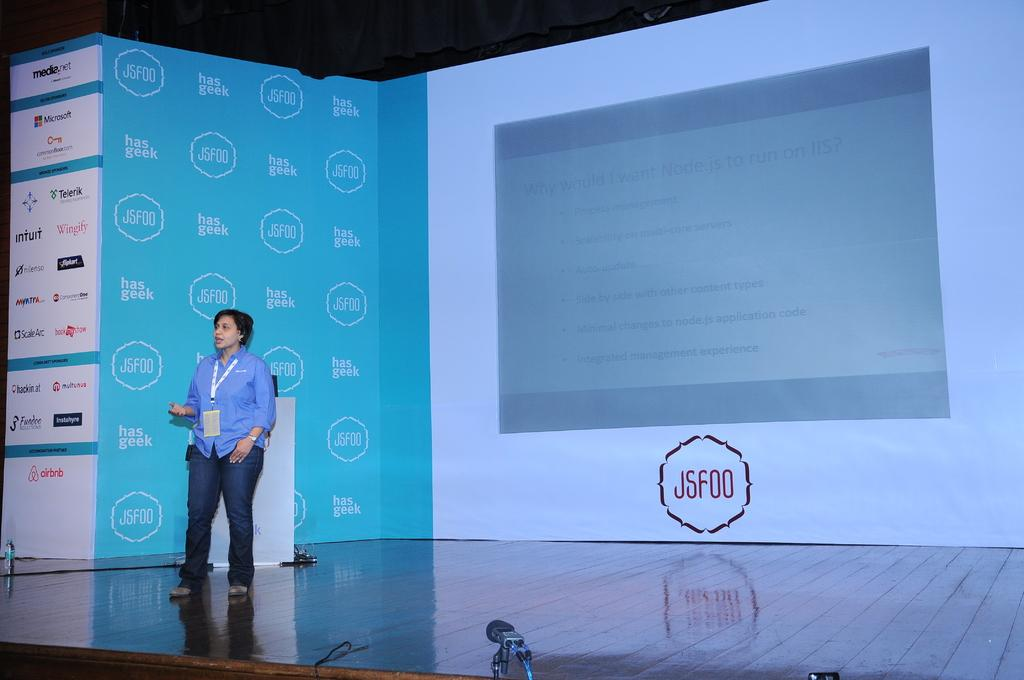What is the main subject of the image? There is a person standing in the image. What can be seen at the bottom of the image? There are objects at the bottom of the image. Where is the bottle located in the image? The bottle is visible on the left side of the image. What is written or displayed on the board in the image? There is a board with text in the image. What type of scent can be detected from the image? There is no information about a scent in the image, so it cannot be determined. 